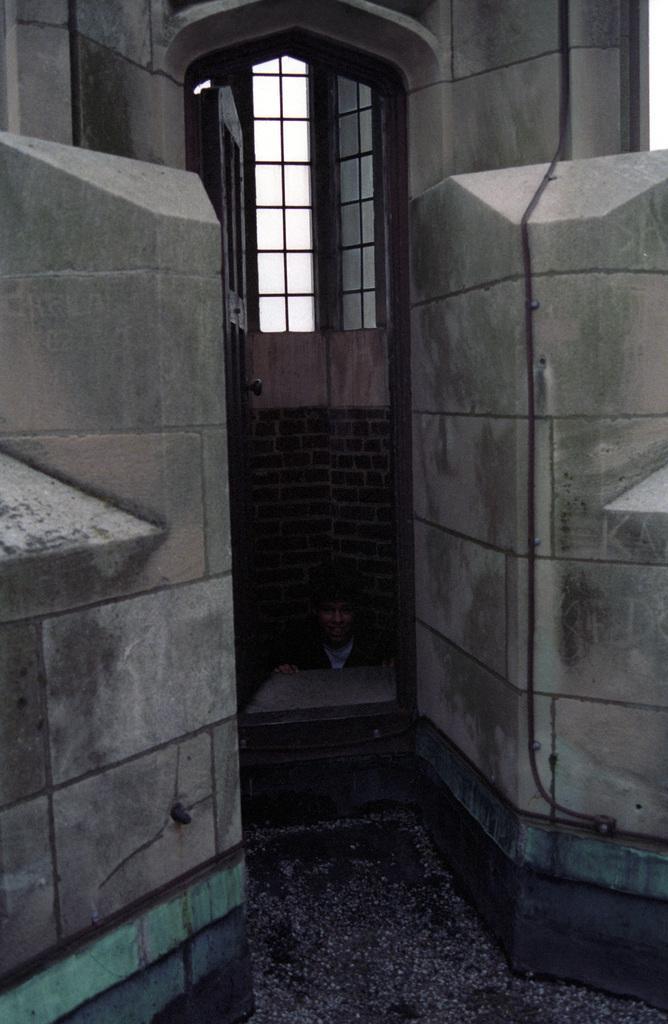Could you give a brief overview of what you see in this image? In this picture, we can able to see brick walls, it is in red color, above it there is a window. In-front of window there is a door. The man is standing between these 2 walls. 